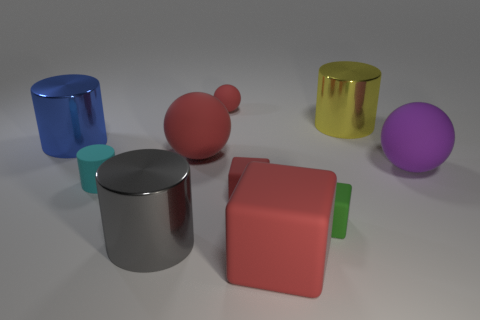What size is the yellow cylinder that is the same material as the large blue object?
Provide a short and direct response. Large. What number of large red objects are the same shape as the cyan thing?
Your answer should be very brief. 0. Is the purple sphere made of the same material as the big red object in front of the tiny cyan rubber cylinder?
Your answer should be compact. Yes. Are there more green rubber things that are behind the green matte thing than big yellow cylinders?
Keep it short and to the point. No. The large thing that is the same color as the big cube is what shape?
Make the answer very short. Sphere. Are there any yellow objects that have the same material as the tiny cyan object?
Your answer should be compact. No. Does the big red thing that is in front of the green cube have the same material as the big ball behind the large purple thing?
Your answer should be compact. Yes. Are there the same number of big cylinders that are to the right of the cyan thing and big yellow objects in front of the big gray shiny cylinder?
Offer a terse response. No. There is a sphere that is the same size as the cyan rubber object; what color is it?
Provide a short and direct response. Red. Is there a object of the same color as the large cube?
Your answer should be compact. Yes. 